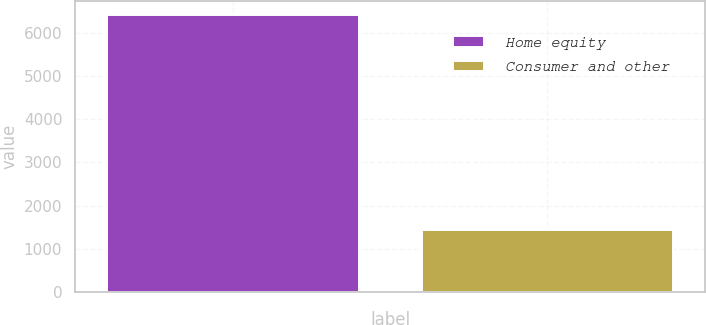<chart> <loc_0><loc_0><loc_500><loc_500><bar_chart><fcel>Home equity<fcel>Consumer and other<nl><fcel>6410.3<fcel>1443.4<nl></chart> 